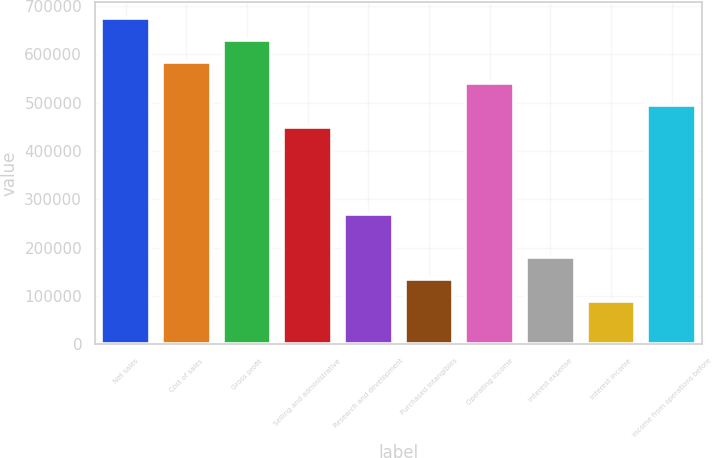Convert chart. <chart><loc_0><loc_0><loc_500><loc_500><bar_chart><fcel>Net sales<fcel>Cost of sales<fcel>Gross profit<fcel>Selling and administrative<fcel>Research and development<fcel>Purchased intangibles<fcel>Operating income<fcel>Interest expense<fcel>Interest income<fcel>Income from operations before<nl><fcel>674927<fcel>584937<fcel>629932<fcel>449952<fcel>269972<fcel>134986<fcel>539942<fcel>179981<fcel>89991.3<fcel>494947<nl></chart> 